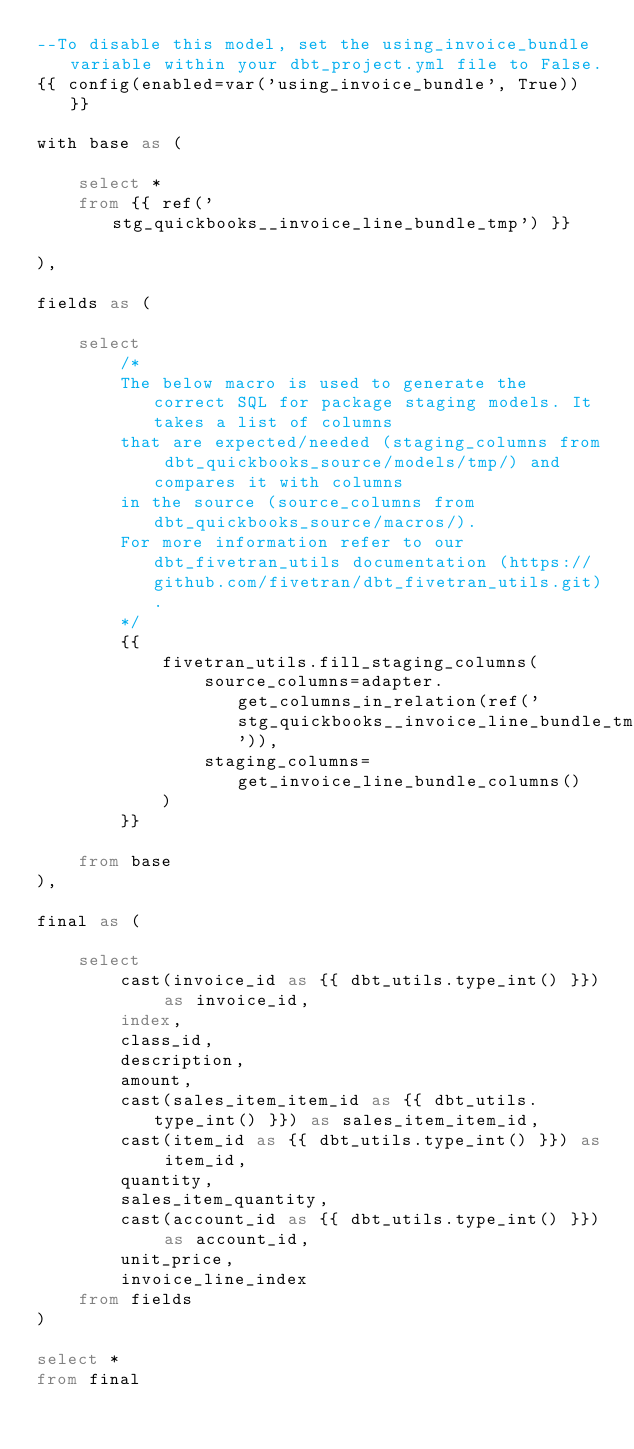<code> <loc_0><loc_0><loc_500><loc_500><_SQL_>--To disable this model, set the using_invoice_bundle variable within your dbt_project.yml file to False.
{{ config(enabled=var('using_invoice_bundle', True)) }}

with base as (

    select * 
    from {{ ref('stg_quickbooks__invoice_line_bundle_tmp') }}

),

fields as (

    select
        /*
        The below macro is used to generate the correct SQL for package staging models. It takes a list of columns 
        that are expected/needed (staging_columns from dbt_quickbooks_source/models/tmp/) and compares it with columns 
        in the source (source_columns from dbt_quickbooks_source/macros/).
        For more information refer to our dbt_fivetran_utils documentation (https://github.com/fivetran/dbt_fivetran_utils.git).
        */
        {{
            fivetran_utils.fill_staging_columns(
                source_columns=adapter.get_columns_in_relation(ref('stg_quickbooks__invoice_line_bundle_tmp')),
                staging_columns=get_invoice_line_bundle_columns()
            )
        }}
        
    from base
),

final as (
    
    select 
        cast(invoice_id as {{ dbt_utils.type_int() }}) as invoice_id,
        index,
        class_id,
        description,
        amount,
        cast(sales_item_item_id as {{ dbt_utils.type_int() }}) as sales_item_item_id,
        cast(item_id as {{ dbt_utils.type_int() }}) as item_id,
        quantity,
        sales_item_quantity,
        cast(account_id as {{ dbt_utils.type_int() }}) as account_id,
        unit_price,
        invoice_line_index
    from fields
)

select * 
from final
</code> 